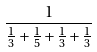Convert formula to latex. <formula><loc_0><loc_0><loc_500><loc_500>\frac { 1 } { \frac { 1 } { 3 } + \frac { 1 } { 5 } + \frac { 1 } { 3 } + \frac { 1 } { 3 } }</formula> 